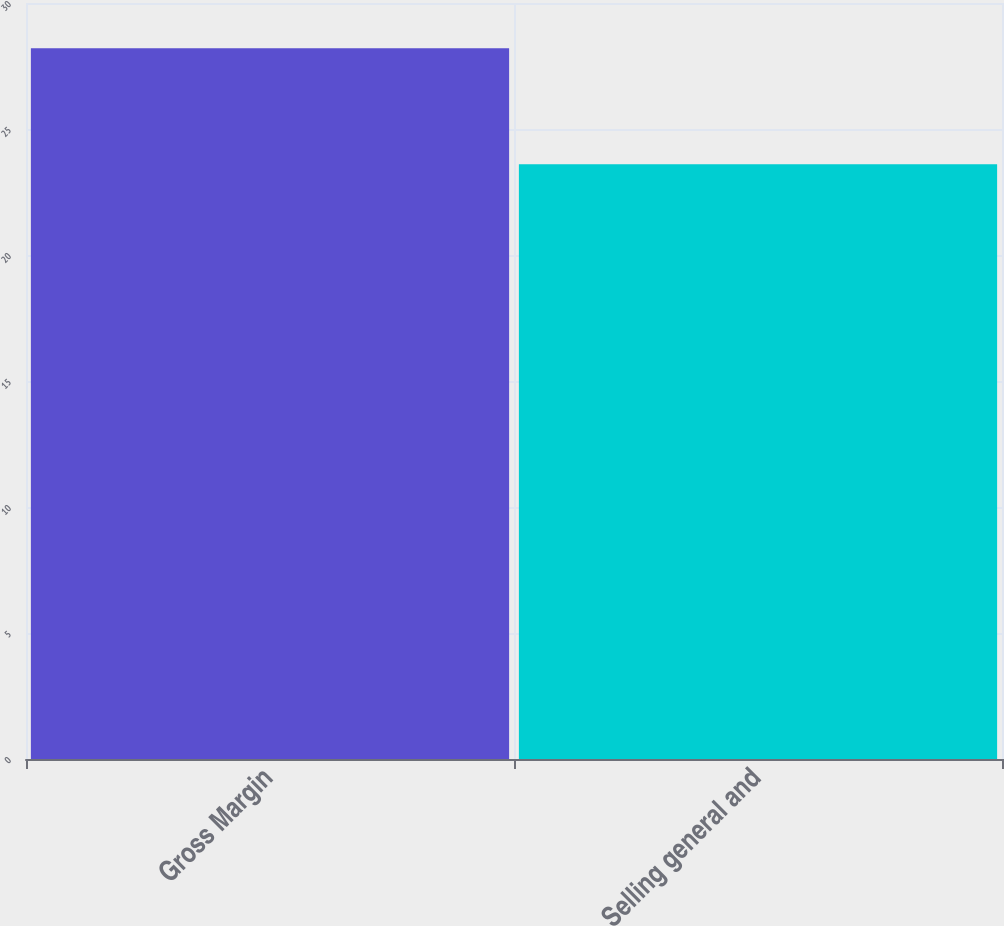Convert chart to OTSL. <chart><loc_0><loc_0><loc_500><loc_500><bar_chart><fcel>Gross Margin<fcel>Selling general and<nl><fcel>28.2<fcel>23.6<nl></chart> 